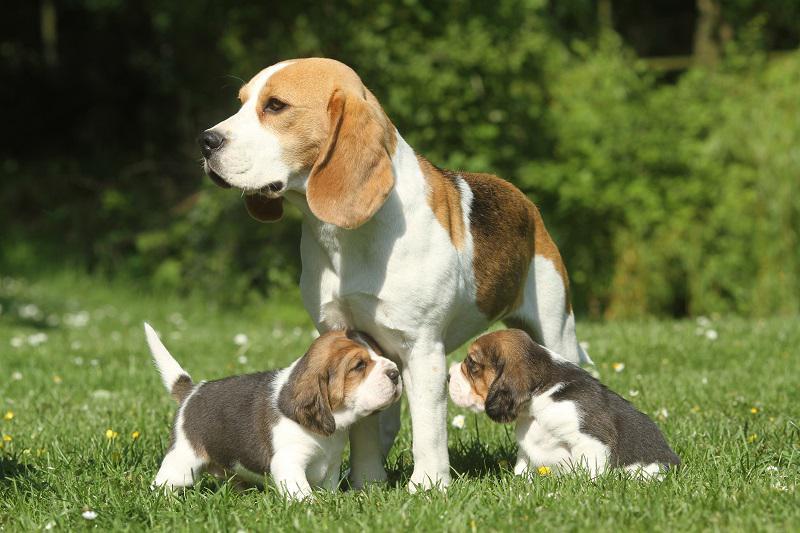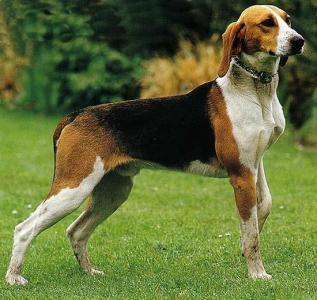The first image is the image on the left, the second image is the image on the right. Given the left and right images, does the statement "The dog in the right image is on a leash." hold true? Answer yes or no. No. 